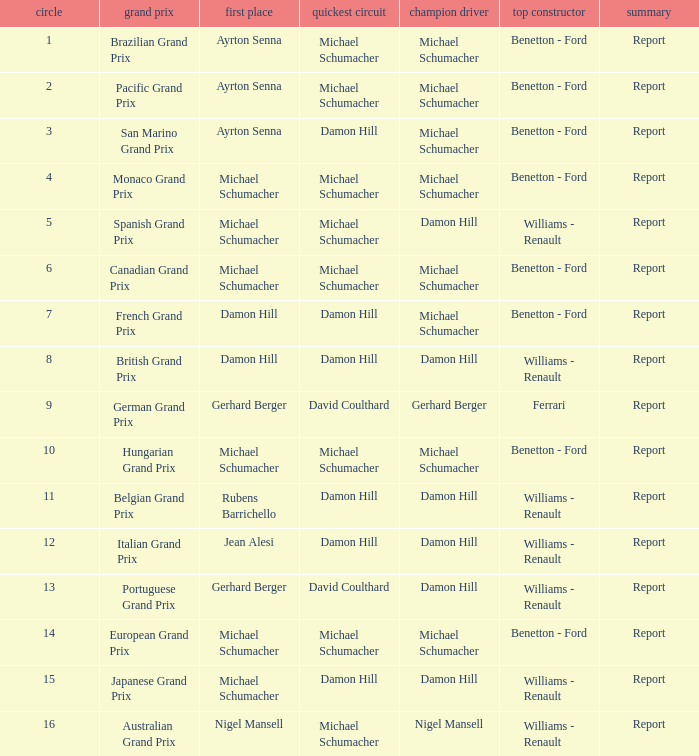Name the lowest round for when pole position and winning driver is michael schumacher 4.0. 